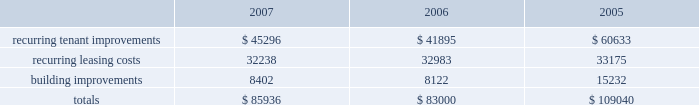In february 2008 , we issued $ 300.0 million of 8.375% ( 8.375 % ) series o cumulative redeemable preferred shares .
The indentures ( and related supplemental indentures ) governing our outstanding series of notes also require us to comply with financial ratios and other covenants regarding our operations .
We were in compliance with all such covenants as of december 31 , 2007 .
Sale of real estate assets we utilize sales of real estate assets as an additional source of liquidity .
We pursue opportunities to sell real estate assets at favorable prices to capture value created by us as well as to improve the overall quality of our portfolio by recycling sale proceeds into new properties with greater value creation opportunities .
Uses of liquidity our principal uses of liquidity include the following : 2022 property investments ; 2022 recurring leasing/capital costs ; 2022 dividends and distributions to shareholders and unitholders ; 2022 long-term debt maturities ; and 2022 other contractual obligations property investments we evaluate development and acquisition opportunities based upon market outlook , supply and long-term growth potential .
Recurring expenditures one of our principal uses of our liquidity is to fund the recurring leasing/capital expenditures of our real estate investments .
The following is a summary of our recurring capital expenditures for the years ended december 31 , 2007 , 2006 and 2005 , respectively ( in thousands ) : .
Dividends and distributions in order to qualify as a reit for federal income tax purposes , we must currently distribute at least 90% ( 90 % ) of our taxable income to shareholders .
We paid dividends per share of $ 1.91 , $ 1.89 and $ 1.87 for the years ended december 31 , 2007 , 2006 and 2005 , respectively .
We also paid a one-time special dividend of $ 1.05 per share in 2005 as a result of the significant gain realized from an industrial portfolio sale .
We expect to continue to distribute taxable earnings to meet the requirements to maintain our reit status .
However , distributions are declared at the discretion of our board of directors and are subject to actual cash available for distribution , our financial condition , capital requirements and such other factors as our board of directors deems relevant .
Debt maturities debt outstanding at december 31 , 2007 totaled $ 4.3 billion with a weighted average interest rate of 5.74% ( 5.74 % ) maturing at various dates through 2028 .
We had $ 3.2 billion of unsecured notes , $ 546.1 million outstanding on our unsecured lines of credit and $ 524.4 million of secured debt outstanding at december 31 , 2007 .
Scheduled principal amortization and maturities of such debt totaled $ 249.8 million for the year ended december 31 , 2007 and $ 146.4 million of secured debt was transferred to unconsolidated subsidiaries in connection with the contribution of properties in 2007. .
In 2007 what was the ratio of the unsecured notes to the outstanding unsecured lines of credit? 
Computations: (3.2 / 546.1)
Answer: 0.00586. 